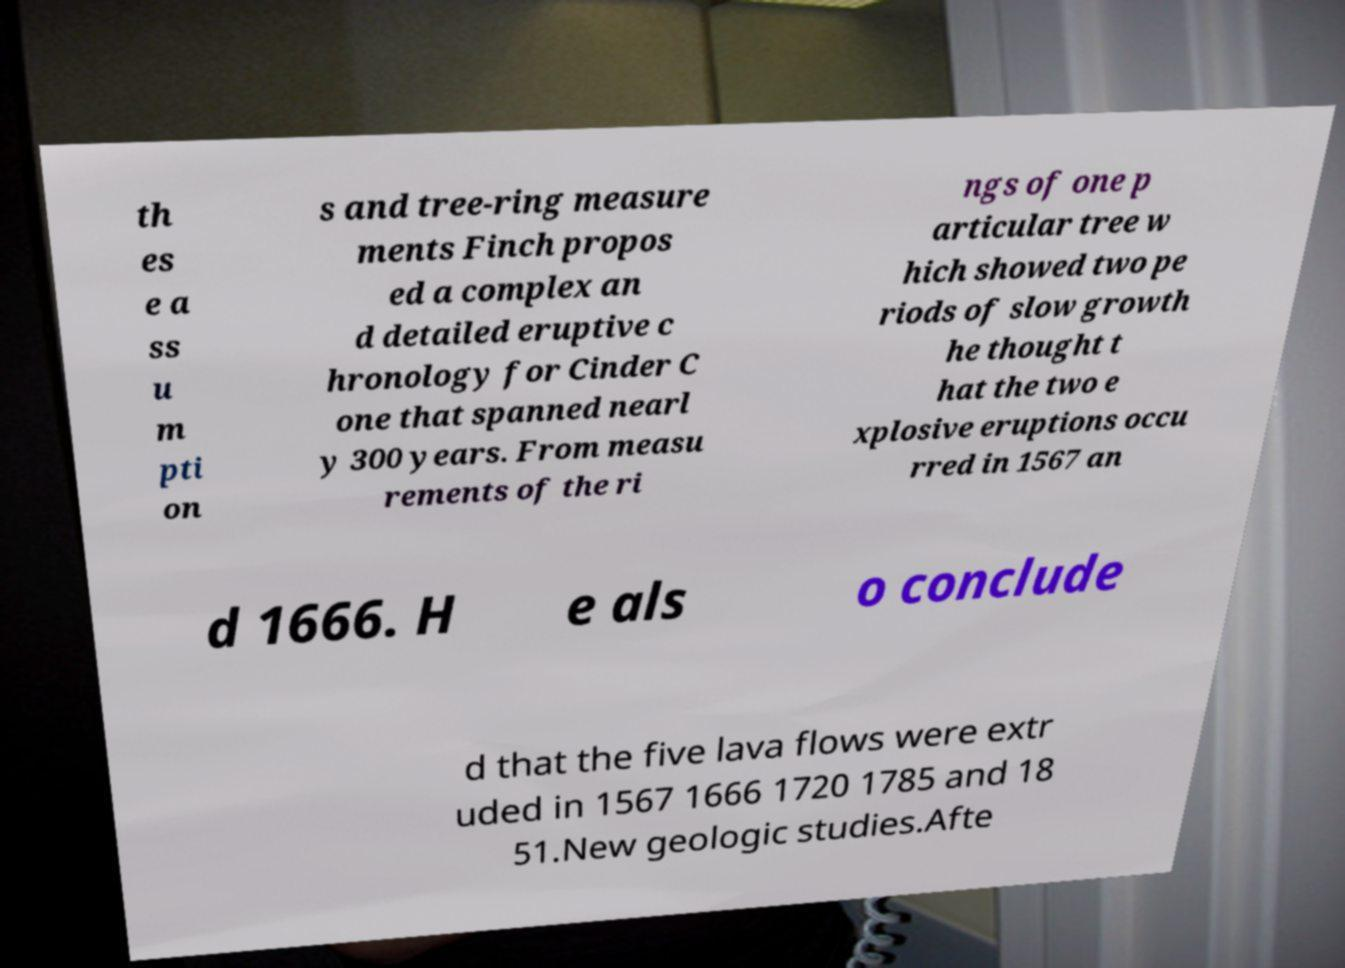Please read and relay the text visible in this image. What does it say? th es e a ss u m pti on s and tree-ring measure ments Finch propos ed a complex an d detailed eruptive c hronology for Cinder C one that spanned nearl y 300 years. From measu rements of the ri ngs of one p articular tree w hich showed two pe riods of slow growth he thought t hat the two e xplosive eruptions occu rred in 1567 an d 1666. H e als o conclude d that the five lava flows were extr uded in 1567 1666 1720 1785 and 18 51.New geologic studies.Afte 